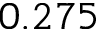<formula> <loc_0><loc_0><loc_500><loc_500>0 . 2 7 5</formula> 